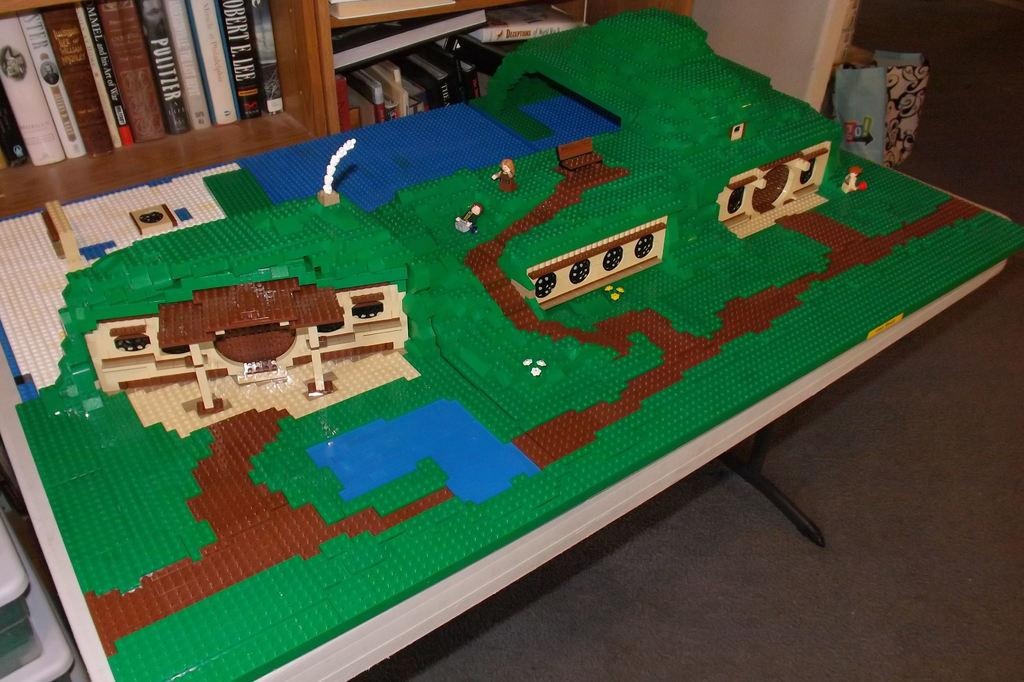What is the setting of the image? The image is of the inside of a room. What is the main piece of furniture in the room? There is a table in the center of the room. What is placed on top of the table? A miniature is placed on top of the table. Where are the books located in the room? There is a cabinet of books in the left corner of the room. What type of cap is the doctor wearing in the image? There is no doctor or cap present in the image. 